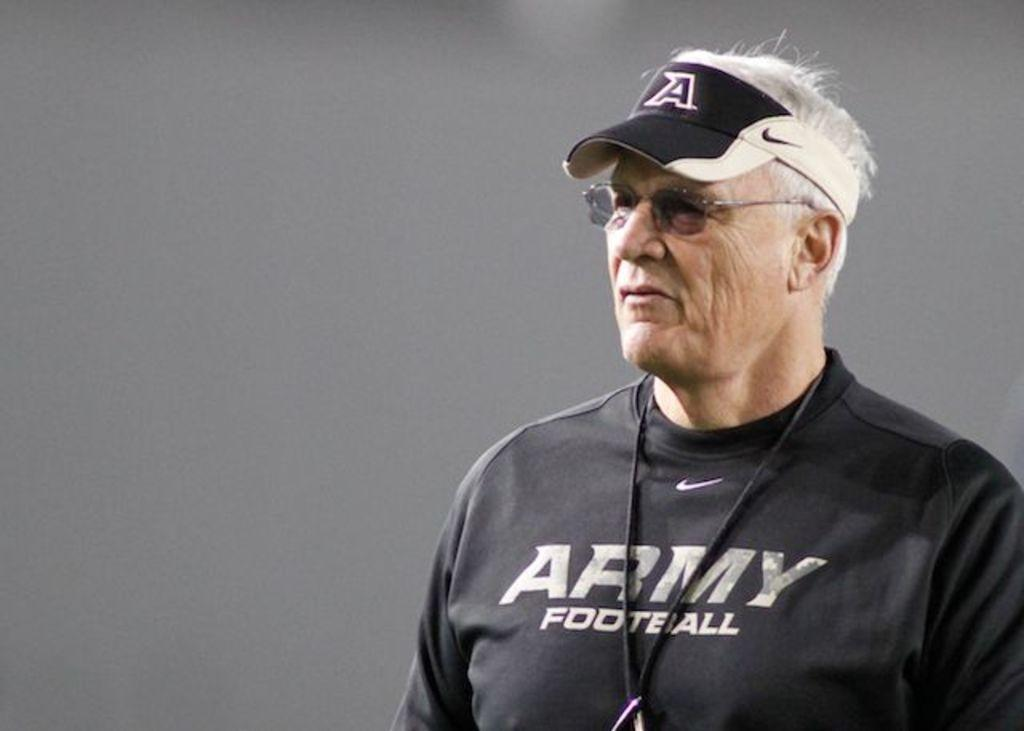<image>
Write a terse but informative summary of the picture. Man wearing a black shirt which says ARMY FOOTBALL. 